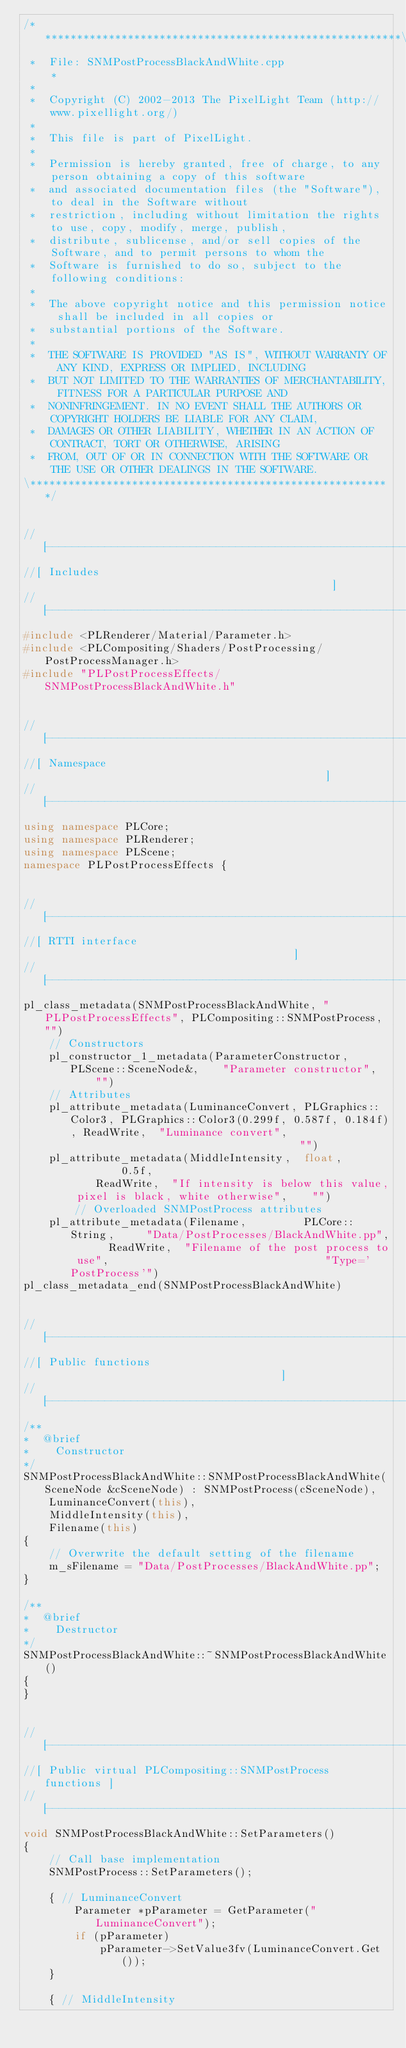<code> <loc_0><loc_0><loc_500><loc_500><_C++_>/*********************************************************\
 *  File: SNMPostProcessBlackAndWhite.cpp                *
 *
 *  Copyright (C) 2002-2013 The PixelLight Team (http://www.pixellight.org/)
 *
 *  This file is part of PixelLight.
 *
 *  Permission is hereby granted, free of charge, to any person obtaining a copy of this software
 *  and associated documentation files (the "Software"), to deal in the Software without
 *  restriction, including without limitation the rights to use, copy, modify, merge, publish,
 *  distribute, sublicense, and/or sell copies of the Software, and to permit persons to whom the
 *  Software is furnished to do so, subject to the following conditions:
 *
 *  The above copyright notice and this permission notice shall be included in all copies or
 *  substantial portions of the Software.
 *
 *  THE SOFTWARE IS PROVIDED "AS IS", WITHOUT WARRANTY OF ANY KIND, EXPRESS OR IMPLIED, INCLUDING
 *  BUT NOT LIMITED TO THE WARRANTIES OF MERCHANTABILITY, FITNESS FOR A PARTICULAR PURPOSE AND
 *  NONINFRINGEMENT. IN NO EVENT SHALL THE AUTHORS OR COPYRIGHT HOLDERS BE LIABLE FOR ANY CLAIM,
 *  DAMAGES OR OTHER LIABILITY, WHETHER IN AN ACTION OF CONTRACT, TORT OR OTHERWISE, ARISING
 *  FROM, OUT OF OR IN CONNECTION WITH THE SOFTWARE OR THE USE OR OTHER DEALINGS IN THE SOFTWARE.
\*********************************************************/


//[-------------------------------------------------------]
//[ Includes                                              ]
//[-------------------------------------------------------]
#include <PLRenderer/Material/Parameter.h>
#include <PLCompositing/Shaders/PostProcessing/PostProcessManager.h>
#include "PLPostProcessEffects/SNMPostProcessBlackAndWhite.h"


//[-------------------------------------------------------]
//[ Namespace                                             ]
//[-------------------------------------------------------]
using namespace PLCore;
using namespace PLRenderer;
using namespace PLScene;
namespace PLPostProcessEffects {


//[-------------------------------------------------------]
//[ RTTI interface                                        ]
//[-------------------------------------------------------]
pl_class_metadata(SNMPostProcessBlackAndWhite, "PLPostProcessEffects", PLCompositing::SNMPostProcess, "")
	// Constructors
	pl_constructor_1_metadata(ParameterConstructor,	PLScene::SceneNode&,	"Parameter constructor",	"")
	// Attributes
	pl_attribute_metadata(LuminanceConvert,	PLGraphics::Color3,	PLGraphics::Color3(0.299f, 0.587f, 0.184f),	ReadWrite,	"Luminance convert",													"")
	pl_attribute_metadata(MiddleIntensity,	float,				0.5f,										ReadWrite,	"If intensity is below this value, pixel is black, white otherwise",	"")
		// Overloaded SNMPostProcess attributes
	pl_attribute_metadata(Filename,			PLCore::String,		"Data/PostProcesses/BlackAndWhite.pp",		ReadWrite,	"Filename of the post process to use",									"Type='PostProcess'")
pl_class_metadata_end(SNMPostProcessBlackAndWhite)


//[-------------------------------------------------------]
//[ Public functions                                      ]
//[-------------------------------------------------------]
/**
*  @brief
*    Constructor
*/
SNMPostProcessBlackAndWhite::SNMPostProcessBlackAndWhite(SceneNode &cSceneNode) : SNMPostProcess(cSceneNode),
	LuminanceConvert(this),
	MiddleIntensity(this),
	Filename(this)
{
	// Overwrite the default setting of the filename
	m_sFilename = "Data/PostProcesses/BlackAndWhite.pp";
}

/**
*  @brief
*    Destructor
*/
SNMPostProcessBlackAndWhite::~SNMPostProcessBlackAndWhite()
{
}


//[-------------------------------------------------------]
//[ Public virtual PLCompositing::SNMPostProcess functions ]
//[-------------------------------------------------------]
void SNMPostProcessBlackAndWhite::SetParameters()
{
	// Call base implementation
	SNMPostProcess::SetParameters();

	{ // LuminanceConvert
		Parameter *pParameter = GetParameter("LuminanceConvert");
		if (pParameter)
			pParameter->SetValue3fv(LuminanceConvert.Get());
	}

	{ // MiddleIntensity</code> 